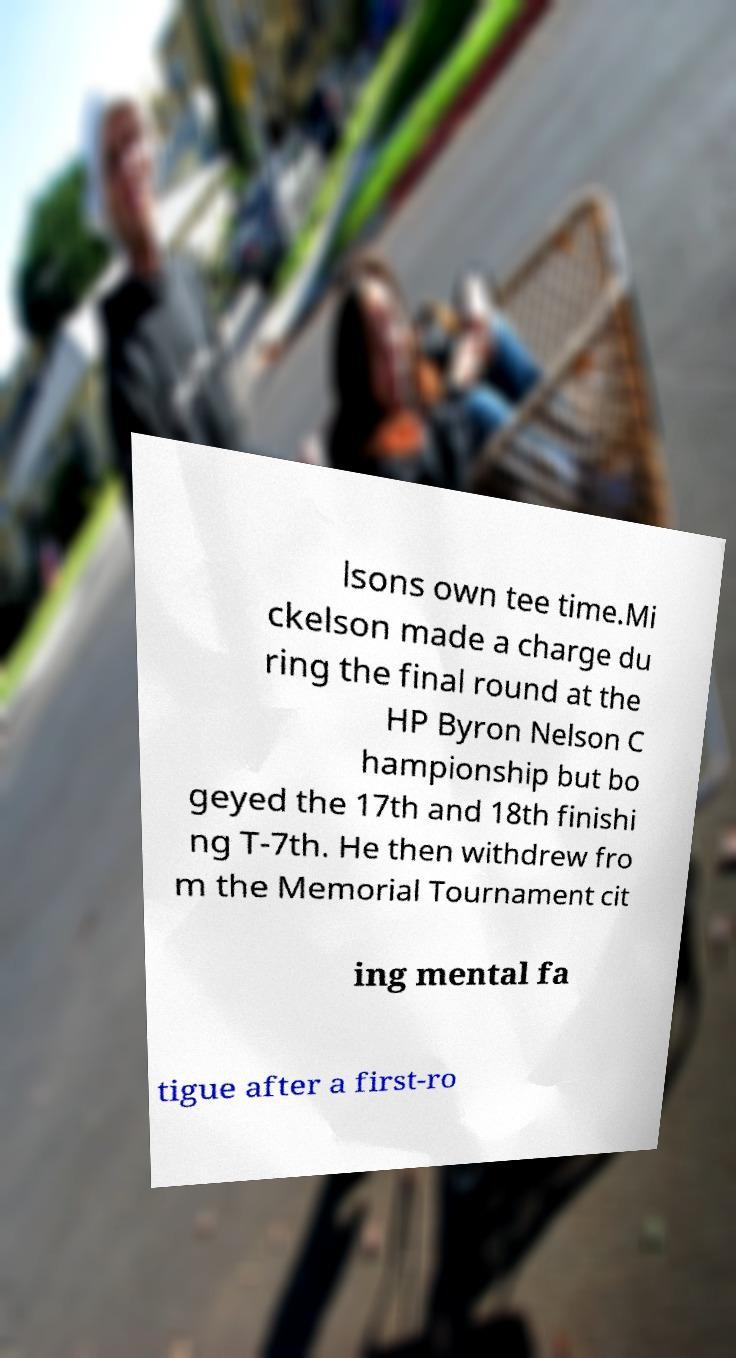Please identify and transcribe the text found in this image. lsons own tee time.Mi ckelson made a charge du ring the final round at the HP Byron Nelson C hampionship but bo geyed the 17th and 18th finishi ng T-7th. He then withdrew fro m the Memorial Tournament cit ing mental fa tigue after a first-ro 